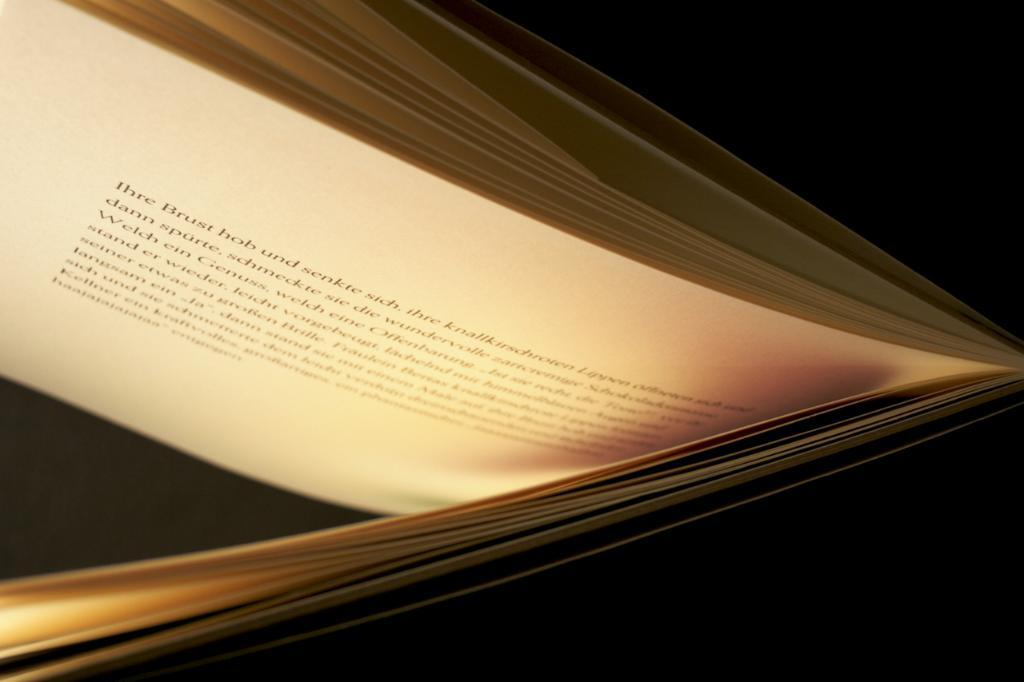What object can be seen in the image? There is a book in the image. What can be found inside the book? There are words written in the book. Can you see any wings on the book in the image? There are no wings present on the book in the image. Is the book being read during the night in the image? We cannot determine the time of day from the provided facts. 